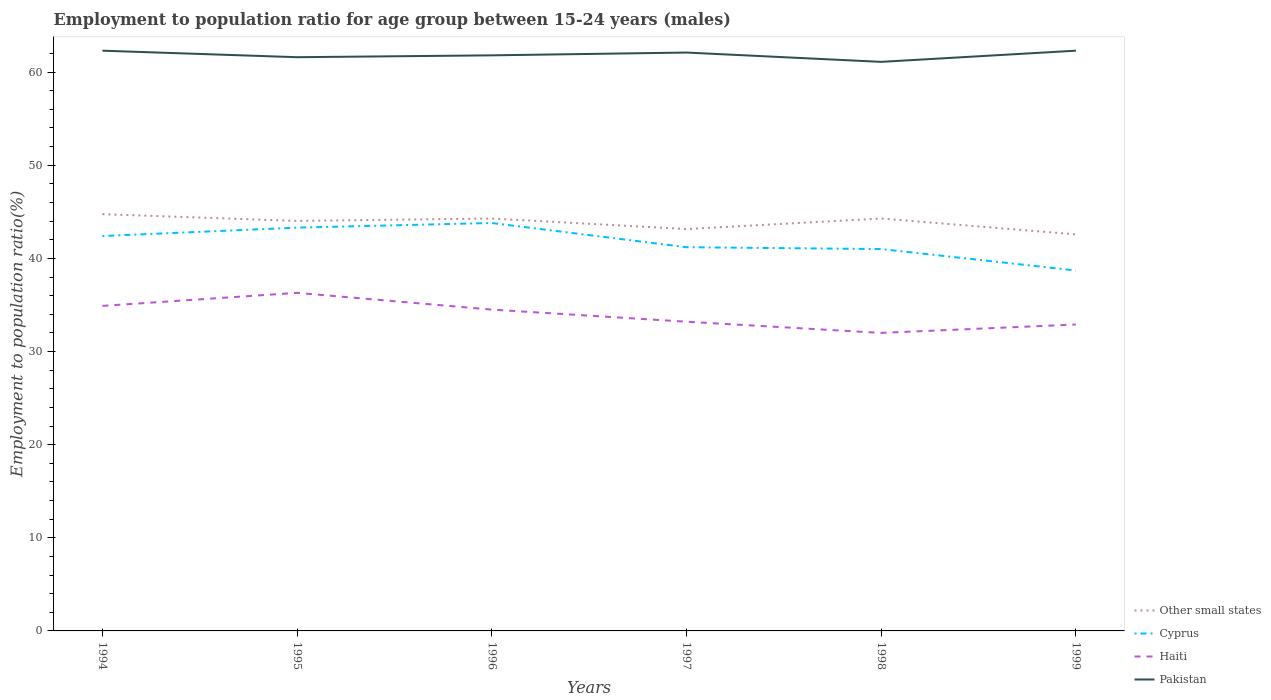Does the line corresponding to Haiti intersect with the line corresponding to Other small states?
Make the answer very short. No. Across all years, what is the maximum employment to population ratio in Other small states?
Your response must be concise. 42.58. In which year was the employment to population ratio in Pakistan maximum?
Your answer should be very brief. 1998. What is the total employment to population ratio in Other small states in the graph?
Provide a short and direct response. 0.57. What is the difference between the highest and the second highest employment to population ratio in Other small states?
Your answer should be very brief. 2.17. Is the employment to population ratio in Haiti strictly greater than the employment to population ratio in Pakistan over the years?
Ensure brevity in your answer.  Yes. How many lines are there?
Ensure brevity in your answer.  4. Does the graph contain any zero values?
Your response must be concise. No. Where does the legend appear in the graph?
Provide a short and direct response. Bottom right. How many legend labels are there?
Provide a short and direct response. 4. How are the legend labels stacked?
Offer a terse response. Vertical. What is the title of the graph?
Provide a short and direct response. Employment to population ratio for age group between 15-24 years (males). Does "Philippines" appear as one of the legend labels in the graph?
Make the answer very short. No. What is the label or title of the X-axis?
Your response must be concise. Years. What is the Employment to population ratio(%) in Other small states in 1994?
Your answer should be very brief. 44.75. What is the Employment to population ratio(%) in Cyprus in 1994?
Offer a terse response. 42.4. What is the Employment to population ratio(%) of Haiti in 1994?
Keep it short and to the point. 34.9. What is the Employment to population ratio(%) in Pakistan in 1994?
Keep it short and to the point. 62.3. What is the Employment to population ratio(%) in Other small states in 1995?
Offer a very short reply. 44.02. What is the Employment to population ratio(%) in Cyprus in 1995?
Give a very brief answer. 43.3. What is the Employment to population ratio(%) in Haiti in 1995?
Provide a short and direct response. 36.3. What is the Employment to population ratio(%) in Pakistan in 1995?
Your answer should be compact. 61.6. What is the Employment to population ratio(%) of Other small states in 1996?
Provide a short and direct response. 44.28. What is the Employment to population ratio(%) in Cyprus in 1996?
Provide a short and direct response. 43.8. What is the Employment to population ratio(%) of Haiti in 1996?
Offer a very short reply. 34.5. What is the Employment to population ratio(%) in Pakistan in 1996?
Your response must be concise. 61.8. What is the Employment to population ratio(%) of Other small states in 1997?
Make the answer very short. 43.15. What is the Employment to population ratio(%) in Cyprus in 1997?
Give a very brief answer. 41.2. What is the Employment to population ratio(%) in Haiti in 1997?
Provide a succinct answer. 33.2. What is the Employment to population ratio(%) of Pakistan in 1997?
Your response must be concise. 62.1. What is the Employment to population ratio(%) of Other small states in 1998?
Ensure brevity in your answer.  44.28. What is the Employment to population ratio(%) in Cyprus in 1998?
Make the answer very short. 41. What is the Employment to population ratio(%) in Haiti in 1998?
Offer a very short reply. 32. What is the Employment to population ratio(%) in Pakistan in 1998?
Offer a terse response. 61.1. What is the Employment to population ratio(%) of Other small states in 1999?
Give a very brief answer. 42.58. What is the Employment to population ratio(%) in Cyprus in 1999?
Offer a very short reply. 38.7. What is the Employment to population ratio(%) of Haiti in 1999?
Make the answer very short. 32.9. What is the Employment to population ratio(%) in Pakistan in 1999?
Ensure brevity in your answer.  62.3. Across all years, what is the maximum Employment to population ratio(%) in Other small states?
Your answer should be very brief. 44.75. Across all years, what is the maximum Employment to population ratio(%) of Cyprus?
Ensure brevity in your answer.  43.8. Across all years, what is the maximum Employment to population ratio(%) in Haiti?
Your response must be concise. 36.3. Across all years, what is the maximum Employment to population ratio(%) in Pakistan?
Your response must be concise. 62.3. Across all years, what is the minimum Employment to population ratio(%) in Other small states?
Your answer should be very brief. 42.58. Across all years, what is the minimum Employment to population ratio(%) in Cyprus?
Make the answer very short. 38.7. Across all years, what is the minimum Employment to population ratio(%) in Pakistan?
Provide a short and direct response. 61.1. What is the total Employment to population ratio(%) of Other small states in the graph?
Your response must be concise. 263.06. What is the total Employment to population ratio(%) of Cyprus in the graph?
Provide a short and direct response. 250.4. What is the total Employment to population ratio(%) in Haiti in the graph?
Ensure brevity in your answer.  203.8. What is the total Employment to population ratio(%) in Pakistan in the graph?
Your answer should be compact. 371.2. What is the difference between the Employment to population ratio(%) of Other small states in 1994 and that in 1995?
Give a very brief answer. 0.73. What is the difference between the Employment to population ratio(%) in Haiti in 1994 and that in 1995?
Your answer should be compact. -1.4. What is the difference between the Employment to population ratio(%) in Pakistan in 1994 and that in 1995?
Give a very brief answer. 0.7. What is the difference between the Employment to population ratio(%) of Other small states in 1994 and that in 1996?
Ensure brevity in your answer.  0.47. What is the difference between the Employment to population ratio(%) of Pakistan in 1994 and that in 1996?
Offer a very short reply. 0.5. What is the difference between the Employment to population ratio(%) in Other small states in 1994 and that in 1997?
Offer a terse response. 1.6. What is the difference between the Employment to population ratio(%) of Pakistan in 1994 and that in 1997?
Give a very brief answer. 0.2. What is the difference between the Employment to population ratio(%) of Other small states in 1994 and that in 1998?
Offer a very short reply. 0.47. What is the difference between the Employment to population ratio(%) of Cyprus in 1994 and that in 1998?
Keep it short and to the point. 1.4. What is the difference between the Employment to population ratio(%) in Haiti in 1994 and that in 1998?
Make the answer very short. 2.9. What is the difference between the Employment to population ratio(%) of Pakistan in 1994 and that in 1998?
Provide a short and direct response. 1.2. What is the difference between the Employment to population ratio(%) in Other small states in 1994 and that in 1999?
Make the answer very short. 2.17. What is the difference between the Employment to population ratio(%) of Cyprus in 1994 and that in 1999?
Offer a very short reply. 3.7. What is the difference between the Employment to population ratio(%) of Pakistan in 1994 and that in 1999?
Provide a succinct answer. 0. What is the difference between the Employment to population ratio(%) of Other small states in 1995 and that in 1996?
Offer a terse response. -0.26. What is the difference between the Employment to population ratio(%) in Cyprus in 1995 and that in 1996?
Ensure brevity in your answer.  -0.5. What is the difference between the Employment to population ratio(%) in Pakistan in 1995 and that in 1996?
Provide a succinct answer. -0.2. What is the difference between the Employment to population ratio(%) of Other small states in 1995 and that in 1997?
Give a very brief answer. 0.87. What is the difference between the Employment to population ratio(%) of Pakistan in 1995 and that in 1997?
Offer a very short reply. -0.5. What is the difference between the Employment to population ratio(%) of Other small states in 1995 and that in 1998?
Offer a very short reply. -0.26. What is the difference between the Employment to population ratio(%) in Pakistan in 1995 and that in 1998?
Your answer should be compact. 0.5. What is the difference between the Employment to population ratio(%) in Other small states in 1995 and that in 1999?
Provide a short and direct response. 1.44. What is the difference between the Employment to population ratio(%) of Cyprus in 1995 and that in 1999?
Your response must be concise. 4.6. What is the difference between the Employment to population ratio(%) of Pakistan in 1995 and that in 1999?
Offer a very short reply. -0.7. What is the difference between the Employment to population ratio(%) in Other small states in 1996 and that in 1997?
Your answer should be compact. 1.13. What is the difference between the Employment to population ratio(%) in Haiti in 1996 and that in 1997?
Ensure brevity in your answer.  1.3. What is the difference between the Employment to population ratio(%) of Pakistan in 1996 and that in 1997?
Keep it short and to the point. -0.3. What is the difference between the Employment to population ratio(%) in Other small states in 1996 and that in 1998?
Provide a short and direct response. -0. What is the difference between the Employment to population ratio(%) of Cyprus in 1996 and that in 1998?
Your answer should be compact. 2.8. What is the difference between the Employment to population ratio(%) in Pakistan in 1996 and that in 1998?
Your answer should be compact. 0.7. What is the difference between the Employment to population ratio(%) of Other small states in 1996 and that in 1999?
Make the answer very short. 1.7. What is the difference between the Employment to population ratio(%) of Haiti in 1996 and that in 1999?
Offer a terse response. 1.6. What is the difference between the Employment to population ratio(%) in Pakistan in 1996 and that in 1999?
Your response must be concise. -0.5. What is the difference between the Employment to population ratio(%) of Other small states in 1997 and that in 1998?
Offer a very short reply. -1.13. What is the difference between the Employment to population ratio(%) of Haiti in 1997 and that in 1998?
Make the answer very short. 1.2. What is the difference between the Employment to population ratio(%) of Other small states in 1997 and that in 1999?
Offer a terse response. 0.57. What is the difference between the Employment to population ratio(%) in Haiti in 1997 and that in 1999?
Keep it short and to the point. 0.3. What is the difference between the Employment to population ratio(%) of Other small states in 1998 and that in 1999?
Your answer should be compact. 1.7. What is the difference between the Employment to population ratio(%) in Cyprus in 1998 and that in 1999?
Keep it short and to the point. 2.3. What is the difference between the Employment to population ratio(%) of Pakistan in 1998 and that in 1999?
Provide a succinct answer. -1.2. What is the difference between the Employment to population ratio(%) in Other small states in 1994 and the Employment to population ratio(%) in Cyprus in 1995?
Keep it short and to the point. 1.45. What is the difference between the Employment to population ratio(%) of Other small states in 1994 and the Employment to population ratio(%) of Haiti in 1995?
Offer a terse response. 8.45. What is the difference between the Employment to population ratio(%) of Other small states in 1994 and the Employment to population ratio(%) of Pakistan in 1995?
Give a very brief answer. -16.85. What is the difference between the Employment to population ratio(%) of Cyprus in 1994 and the Employment to population ratio(%) of Pakistan in 1995?
Give a very brief answer. -19.2. What is the difference between the Employment to population ratio(%) of Haiti in 1994 and the Employment to population ratio(%) of Pakistan in 1995?
Provide a short and direct response. -26.7. What is the difference between the Employment to population ratio(%) in Other small states in 1994 and the Employment to population ratio(%) in Cyprus in 1996?
Offer a terse response. 0.95. What is the difference between the Employment to population ratio(%) in Other small states in 1994 and the Employment to population ratio(%) in Haiti in 1996?
Give a very brief answer. 10.25. What is the difference between the Employment to population ratio(%) of Other small states in 1994 and the Employment to population ratio(%) of Pakistan in 1996?
Provide a short and direct response. -17.05. What is the difference between the Employment to population ratio(%) of Cyprus in 1994 and the Employment to population ratio(%) of Pakistan in 1996?
Offer a very short reply. -19.4. What is the difference between the Employment to population ratio(%) of Haiti in 1994 and the Employment to population ratio(%) of Pakistan in 1996?
Provide a succinct answer. -26.9. What is the difference between the Employment to population ratio(%) of Other small states in 1994 and the Employment to population ratio(%) of Cyprus in 1997?
Your answer should be very brief. 3.55. What is the difference between the Employment to population ratio(%) of Other small states in 1994 and the Employment to population ratio(%) of Haiti in 1997?
Ensure brevity in your answer.  11.55. What is the difference between the Employment to population ratio(%) in Other small states in 1994 and the Employment to population ratio(%) in Pakistan in 1997?
Provide a succinct answer. -17.35. What is the difference between the Employment to population ratio(%) in Cyprus in 1994 and the Employment to population ratio(%) in Haiti in 1997?
Provide a short and direct response. 9.2. What is the difference between the Employment to population ratio(%) of Cyprus in 1994 and the Employment to population ratio(%) of Pakistan in 1997?
Give a very brief answer. -19.7. What is the difference between the Employment to population ratio(%) of Haiti in 1994 and the Employment to population ratio(%) of Pakistan in 1997?
Offer a very short reply. -27.2. What is the difference between the Employment to population ratio(%) in Other small states in 1994 and the Employment to population ratio(%) in Cyprus in 1998?
Keep it short and to the point. 3.75. What is the difference between the Employment to population ratio(%) in Other small states in 1994 and the Employment to population ratio(%) in Haiti in 1998?
Your answer should be very brief. 12.75. What is the difference between the Employment to population ratio(%) of Other small states in 1994 and the Employment to population ratio(%) of Pakistan in 1998?
Provide a succinct answer. -16.35. What is the difference between the Employment to population ratio(%) in Cyprus in 1994 and the Employment to population ratio(%) in Haiti in 1998?
Ensure brevity in your answer.  10.4. What is the difference between the Employment to population ratio(%) in Cyprus in 1994 and the Employment to population ratio(%) in Pakistan in 1998?
Your answer should be compact. -18.7. What is the difference between the Employment to population ratio(%) in Haiti in 1994 and the Employment to population ratio(%) in Pakistan in 1998?
Ensure brevity in your answer.  -26.2. What is the difference between the Employment to population ratio(%) in Other small states in 1994 and the Employment to population ratio(%) in Cyprus in 1999?
Your answer should be very brief. 6.05. What is the difference between the Employment to population ratio(%) of Other small states in 1994 and the Employment to population ratio(%) of Haiti in 1999?
Your response must be concise. 11.85. What is the difference between the Employment to population ratio(%) in Other small states in 1994 and the Employment to population ratio(%) in Pakistan in 1999?
Keep it short and to the point. -17.55. What is the difference between the Employment to population ratio(%) of Cyprus in 1994 and the Employment to population ratio(%) of Pakistan in 1999?
Ensure brevity in your answer.  -19.9. What is the difference between the Employment to population ratio(%) in Haiti in 1994 and the Employment to population ratio(%) in Pakistan in 1999?
Offer a terse response. -27.4. What is the difference between the Employment to population ratio(%) in Other small states in 1995 and the Employment to population ratio(%) in Cyprus in 1996?
Ensure brevity in your answer.  0.22. What is the difference between the Employment to population ratio(%) of Other small states in 1995 and the Employment to population ratio(%) of Haiti in 1996?
Give a very brief answer. 9.52. What is the difference between the Employment to population ratio(%) in Other small states in 1995 and the Employment to population ratio(%) in Pakistan in 1996?
Provide a succinct answer. -17.78. What is the difference between the Employment to population ratio(%) of Cyprus in 1995 and the Employment to population ratio(%) of Haiti in 1996?
Your answer should be very brief. 8.8. What is the difference between the Employment to population ratio(%) in Cyprus in 1995 and the Employment to population ratio(%) in Pakistan in 1996?
Offer a terse response. -18.5. What is the difference between the Employment to population ratio(%) of Haiti in 1995 and the Employment to population ratio(%) of Pakistan in 1996?
Give a very brief answer. -25.5. What is the difference between the Employment to population ratio(%) in Other small states in 1995 and the Employment to population ratio(%) in Cyprus in 1997?
Offer a terse response. 2.82. What is the difference between the Employment to population ratio(%) in Other small states in 1995 and the Employment to population ratio(%) in Haiti in 1997?
Offer a terse response. 10.82. What is the difference between the Employment to population ratio(%) of Other small states in 1995 and the Employment to population ratio(%) of Pakistan in 1997?
Keep it short and to the point. -18.08. What is the difference between the Employment to population ratio(%) in Cyprus in 1995 and the Employment to population ratio(%) in Haiti in 1997?
Provide a short and direct response. 10.1. What is the difference between the Employment to population ratio(%) of Cyprus in 1995 and the Employment to population ratio(%) of Pakistan in 1997?
Make the answer very short. -18.8. What is the difference between the Employment to population ratio(%) of Haiti in 1995 and the Employment to population ratio(%) of Pakistan in 1997?
Make the answer very short. -25.8. What is the difference between the Employment to population ratio(%) in Other small states in 1995 and the Employment to population ratio(%) in Cyprus in 1998?
Ensure brevity in your answer.  3.02. What is the difference between the Employment to population ratio(%) in Other small states in 1995 and the Employment to population ratio(%) in Haiti in 1998?
Offer a terse response. 12.02. What is the difference between the Employment to population ratio(%) in Other small states in 1995 and the Employment to population ratio(%) in Pakistan in 1998?
Your response must be concise. -17.08. What is the difference between the Employment to population ratio(%) of Cyprus in 1995 and the Employment to population ratio(%) of Haiti in 1998?
Offer a very short reply. 11.3. What is the difference between the Employment to population ratio(%) of Cyprus in 1995 and the Employment to population ratio(%) of Pakistan in 1998?
Keep it short and to the point. -17.8. What is the difference between the Employment to population ratio(%) in Haiti in 1995 and the Employment to population ratio(%) in Pakistan in 1998?
Ensure brevity in your answer.  -24.8. What is the difference between the Employment to population ratio(%) in Other small states in 1995 and the Employment to population ratio(%) in Cyprus in 1999?
Give a very brief answer. 5.32. What is the difference between the Employment to population ratio(%) in Other small states in 1995 and the Employment to population ratio(%) in Haiti in 1999?
Your answer should be compact. 11.12. What is the difference between the Employment to population ratio(%) in Other small states in 1995 and the Employment to population ratio(%) in Pakistan in 1999?
Ensure brevity in your answer.  -18.28. What is the difference between the Employment to population ratio(%) of Cyprus in 1995 and the Employment to population ratio(%) of Pakistan in 1999?
Provide a succinct answer. -19. What is the difference between the Employment to population ratio(%) of Haiti in 1995 and the Employment to population ratio(%) of Pakistan in 1999?
Offer a very short reply. -26. What is the difference between the Employment to population ratio(%) of Other small states in 1996 and the Employment to population ratio(%) of Cyprus in 1997?
Offer a very short reply. 3.08. What is the difference between the Employment to population ratio(%) in Other small states in 1996 and the Employment to population ratio(%) in Haiti in 1997?
Make the answer very short. 11.08. What is the difference between the Employment to population ratio(%) in Other small states in 1996 and the Employment to population ratio(%) in Pakistan in 1997?
Provide a short and direct response. -17.82. What is the difference between the Employment to population ratio(%) in Cyprus in 1996 and the Employment to population ratio(%) in Haiti in 1997?
Offer a terse response. 10.6. What is the difference between the Employment to population ratio(%) of Cyprus in 1996 and the Employment to population ratio(%) of Pakistan in 1997?
Make the answer very short. -18.3. What is the difference between the Employment to population ratio(%) in Haiti in 1996 and the Employment to population ratio(%) in Pakistan in 1997?
Give a very brief answer. -27.6. What is the difference between the Employment to population ratio(%) in Other small states in 1996 and the Employment to population ratio(%) in Cyprus in 1998?
Make the answer very short. 3.28. What is the difference between the Employment to population ratio(%) of Other small states in 1996 and the Employment to population ratio(%) of Haiti in 1998?
Your answer should be very brief. 12.28. What is the difference between the Employment to population ratio(%) in Other small states in 1996 and the Employment to population ratio(%) in Pakistan in 1998?
Provide a short and direct response. -16.82. What is the difference between the Employment to population ratio(%) of Cyprus in 1996 and the Employment to population ratio(%) of Pakistan in 1998?
Offer a terse response. -17.3. What is the difference between the Employment to population ratio(%) in Haiti in 1996 and the Employment to population ratio(%) in Pakistan in 1998?
Your answer should be very brief. -26.6. What is the difference between the Employment to population ratio(%) in Other small states in 1996 and the Employment to population ratio(%) in Cyprus in 1999?
Keep it short and to the point. 5.58. What is the difference between the Employment to population ratio(%) in Other small states in 1996 and the Employment to population ratio(%) in Haiti in 1999?
Your answer should be very brief. 11.38. What is the difference between the Employment to population ratio(%) in Other small states in 1996 and the Employment to population ratio(%) in Pakistan in 1999?
Your response must be concise. -18.02. What is the difference between the Employment to population ratio(%) in Cyprus in 1996 and the Employment to population ratio(%) in Haiti in 1999?
Provide a short and direct response. 10.9. What is the difference between the Employment to population ratio(%) in Cyprus in 1996 and the Employment to population ratio(%) in Pakistan in 1999?
Provide a succinct answer. -18.5. What is the difference between the Employment to population ratio(%) of Haiti in 1996 and the Employment to population ratio(%) of Pakistan in 1999?
Offer a terse response. -27.8. What is the difference between the Employment to population ratio(%) in Other small states in 1997 and the Employment to population ratio(%) in Cyprus in 1998?
Ensure brevity in your answer.  2.15. What is the difference between the Employment to population ratio(%) of Other small states in 1997 and the Employment to population ratio(%) of Haiti in 1998?
Your response must be concise. 11.15. What is the difference between the Employment to population ratio(%) of Other small states in 1997 and the Employment to population ratio(%) of Pakistan in 1998?
Ensure brevity in your answer.  -17.95. What is the difference between the Employment to population ratio(%) of Cyprus in 1997 and the Employment to population ratio(%) of Pakistan in 1998?
Make the answer very short. -19.9. What is the difference between the Employment to population ratio(%) in Haiti in 1997 and the Employment to population ratio(%) in Pakistan in 1998?
Keep it short and to the point. -27.9. What is the difference between the Employment to population ratio(%) of Other small states in 1997 and the Employment to population ratio(%) of Cyprus in 1999?
Your answer should be very brief. 4.45. What is the difference between the Employment to population ratio(%) in Other small states in 1997 and the Employment to population ratio(%) in Haiti in 1999?
Offer a terse response. 10.25. What is the difference between the Employment to population ratio(%) in Other small states in 1997 and the Employment to population ratio(%) in Pakistan in 1999?
Your answer should be compact. -19.15. What is the difference between the Employment to population ratio(%) in Cyprus in 1997 and the Employment to population ratio(%) in Pakistan in 1999?
Offer a very short reply. -21.1. What is the difference between the Employment to population ratio(%) of Haiti in 1997 and the Employment to population ratio(%) of Pakistan in 1999?
Offer a very short reply. -29.1. What is the difference between the Employment to population ratio(%) in Other small states in 1998 and the Employment to population ratio(%) in Cyprus in 1999?
Offer a terse response. 5.58. What is the difference between the Employment to population ratio(%) of Other small states in 1998 and the Employment to population ratio(%) of Haiti in 1999?
Make the answer very short. 11.38. What is the difference between the Employment to population ratio(%) of Other small states in 1998 and the Employment to population ratio(%) of Pakistan in 1999?
Make the answer very short. -18.02. What is the difference between the Employment to population ratio(%) of Cyprus in 1998 and the Employment to population ratio(%) of Haiti in 1999?
Your answer should be compact. 8.1. What is the difference between the Employment to population ratio(%) of Cyprus in 1998 and the Employment to population ratio(%) of Pakistan in 1999?
Offer a very short reply. -21.3. What is the difference between the Employment to population ratio(%) in Haiti in 1998 and the Employment to population ratio(%) in Pakistan in 1999?
Provide a succinct answer. -30.3. What is the average Employment to population ratio(%) of Other small states per year?
Your answer should be very brief. 43.84. What is the average Employment to population ratio(%) of Cyprus per year?
Ensure brevity in your answer.  41.73. What is the average Employment to population ratio(%) in Haiti per year?
Offer a terse response. 33.97. What is the average Employment to population ratio(%) of Pakistan per year?
Make the answer very short. 61.87. In the year 1994, what is the difference between the Employment to population ratio(%) in Other small states and Employment to population ratio(%) in Cyprus?
Provide a short and direct response. 2.35. In the year 1994, what is the difference between the Employment to population ratio(%) in Other small states and Employment to population ratio(%) in Haiti?
Ensure brevity in your answer.  9.85. In the year 1994, what is the difference between the Employment to population ratio(%) in Other small states and Employment to population ratio(%) in Pakistan?
Provide a short and direct response. -17.55. In the year 1994, what is the difference between the Employment to population ratio(%) of Cyprus and Employment to population ratio(%) of Pakistan?
Your answer should be very brief. -19.9. In the year 1994, what is the difference between the Employment to population ratio(%) in Haiti and Employment to population ratio(%) in Pakistan?
Provide a succinct answer. -27.4. In the year 1995, what is the difference between the Employment to population ratio(%) of Other small states and Employment to population ratio(%) of Cyprus?
Your answer should be very brief. 0.72. In the year 1995, what is the difference between the Employment to population ratio(%) of Other small states and Employment to population ratio(%) of Haiti?
Provide a short and direct response. 7.72. In the year 1995, what is the difference between the Employment to population ratio(%) in Other small states and Employment to population ratio(%) in Pakistan?
Make the answer very short. -17.58. In the year 1995, what is the difference between the Employment to population ratio(%) of Cyprus and Employment to population ratio(%) of Pakistan?
Your answer should be very brief. -18.3. In the year 1995, what is the difference between the Employment to population ratio(%) of Haiti and Employment to population ratio(%) of Pakistan?
Offer a very short reply. -25.3. In the year 1996, what is the difference between the Employment to population ratio(%) of Other small states and Employment to population ratio(%) of Cyprus?
Your answer should be very brief. 0.48. In the year 1996, what is the difference between the Employment to population ratio(%) of Other small states and Employment to population ratio(%) of Haiti?
Offer a very short reply. 9.78. In the year 1996, what is the difference between the Employment to population ratio(%) in Other small states and Employment to population ratio(%) in Pakistan?
Offer a terse response. -17.52. In the year 1996, what is the difference between the Employment to population ratio(%) of Haiti and Employment to population ratio(%) of Pakistan?
Provide a succinct answer. -27.3. In the year 1997, what is the difference between the Employment to population ratio(%) in Other small states and Employment to population ratio(%) in Cyprus?
Your answer should be very brief. 1.95. In the year 1997, what is the difference between the Employment to population ratio(%) in Other small states and Employment to population ratio(%) in Haiti?
Your answer should be very brief. 9.95. In the year 1997, what is the difference between the Employment to population ratio(%) in Other small states and Employment to population ratio(%) in Pakistan?
Give a very brief answer. -18.95. In the year 1997, what is the difference between the Employment to population ratio(%) in Cyprus and Employment to population ratio(%) in Pakistan?
Your answer should be compact. -20.9. In the year 1997, what is the difference between the Employment to population ratio(%) of Haiti and Employment to population ratio(%) of Pakistan?
Give a very brief answer. -28.9. In the year 1998, what is the difference between the Employment to population ratio(%) of Other small states and Employment to population ratio(%) of Cyprus?
Ensure brevity in your answer.  3.28. In the year 1998, what is the difference between the Employment to population ratio(%) of Other small states and Employment to population ratio(%) of Haiti?
Your response must be concise. 12.28. In the year 1998, what is the difference between the Employment to population ratio(%) of Other small states and Employment to population ratio(%) of Pakistan?
Provide a succinct answer. -16.82. In the year 1998, what is the difference between the Employment to population ratio(%) of Cyprus and Employment to population ratio(%) of Haiti?
Your response must be concise. 9. In the year 1998, what is the difference between the Employment to population ratio(%) in Cyprus and Employment to population ratio(%) in Pakistan?
Your response must be concise. -20.1. In the year 1998, what is the difference between the Employment to population ratio(%) of Haiti and Employment to population ratio(%) of Pakistan?
Offer a very short reply. -29.1. In the year 1999, what is the difference between the Employment to population ratio(%) in Other small states and Employment to population ratio(%) in Cyprus?
Make the answer very short. 3.88. In the year 1999, what is the difference between the Employment to population ratio(%) of Other small states and Employment to population ratio(%) of Haiti?
Offer a very short reply. 9.68. In the year 1999, what is the difference between the Employment to population ratio(%) in Other small states and Employment to population ratio(%) in Pakistan?
Provide a succinct answer. -19.72. In the year 1999, what is the difference between the Employment to population ratio(%) in Cyprus and Employment to population ratio(%) in Pakistan?
Provide a succinct answer. -23.6. In the year 1999, what is the difference between the Employment to population ratio(%) in Haiti and Employment to population ratio(%) in Pakistan?
Your response must be concise. -29.4. What is the ratio of the Employment to population ratio(%) in Other small states in 1994 to that in 1995?
Provide a short and direct response. 1.02. What is the ratio of the Employment to population ratio(%) in Cyprus in 1994 to that in 1995?
Keep it short and to the point. 0.98. What is the ratio of the Employment to population ratio(%) of Haiti in 1994 to that in 1995?
Offer a terse response. 0.96. What is the ratio of the Employment to population ratio(%) of Pakistan in 1994 to that in 1995?
Make the answer very short. 1.01. What is the ratio of the Employment to population ratio(%) in Other small states in 1994 to that in 1996?
Offer a very short reply. 1.01. What is the ratio of the Employment to population ratio(%) of Haiti in 1994 to that in 1996?
Offer a terse response. 1.01. What is the ratio of the Employment to population ratio(%) of Pakistan in 1994 to that in 1996?
Your answer should be very brief. 1.01. What is the ratio of the Employment to population ratio(%) in Other small states in 1994 to that in 1997?
Ensure brevity in your answer.  1.04. What is the ratio of the Employment to population ratio(%) of Cyprus in 1994 to that in 1997?
Ensure brevity in your answer.  1.03. What is the ratio of the Employment to population ratio(%) in Haiti in 1994 to that in 1997?
Give a very brief answer. 1.05. What is the ratio of the Employment to population ratio(%) of Pakistan in 1994 to that in 1997?
Your answer should be very brief. 1. What is the ratio of the Employment to population ratio(%) in Other small states in 1994 to that in 1998?
Keep it short and to the point. 1.01. What is the ratio of the Employment to population ratio(%) of Cyprus in 1994 to that in 1998?
Offer a terse response. 1.03. What is the ratio of the Employment to population ratio(%) in Haiti in 1994 to that in 1998?
Give a very brief answer. 1.09. What is the ratio of the Employment to population ratio(%) of Pakistan in 1994 to that in 1998?
Offer a very short reply. 1.02. What is the ratio of the Employment to population ratio(%) of Other small states in 1994 to that in 1999?
Ensure brevity in your answer.  1.05. What is the ratio of the Employment to population ratio(%) of Cyprus in 1994 to that in 1999?
Ensure brevity in your answer.  1.1. What is the ratio of the Employment to population ratio(%) of Haiti in 1994 to that in 1999?
Offer a very short reply. 1.06. What is the ratio of the Employment to population ratio(%) of Haiti in 1995 to that in 1996?
Keep it short and to the point. 1.05. What is the ratio of the Employment to population ratio(%) in Other small states in 1995 to that in 1997?
Give a very brief answer. 1.02. What is the ratio of the Employment to population ratio(%) of Cyprus in 1995 to that in 1997?
Provide a short and direct response. 1.05. What is the ratio of the Employment to population ratio(%) of Haiti in 1995 to that in 1997?
Your answer should be very brief. 1.09. What is the ratio of the Employment to population ratio(%) in Cyprus in 1995 to that in 1998?
Make the answer very short. 1.06. What is the ratio of the Employment to population ratio(%) of Haiti in 1995 to that in 1998?
Ensure brevity in your answer.  1.13. What is the ratio of the Employment to population ratio(%) of Pakistan in 1995 to that in 1998?
Keep it short and to the point. 1.01. What is the ratio of the Employment to population ratio(%) in Other small states in 1995 to that in 1999?
Your answer should be compact. 1.03. What is the ratio of the Employment to population ratio(%) in Cyprus in 1995 to that in 1999?
Your answer should be compact. 1.12. What is the ratio of the Employment to population ratio(%) in Haiti in 1995 to that in 1999?
Give a very brief answer. 1.1. What is the ratio of the Employment to population ratio(%) of Pakistan in 1995 to that in 1999?
Offer a very short reply. 0.99. What is the ratio of the Employment to population ratio(%) in Other small states in 1996 to that in 1997?
Provide a succinct answer. 1.03. What is the ratio of the Employment to population ratio(%) in Cyprus in 1996 to that in 1997?
Your response must be concise. 1.06. What is the ratio of the Employment to population ratio(%) of Haiti in 1996 to that in 1997?
Your response must be concise. 1.04. What is the ratio of the Employment to population ratio(%) in Cyprus in 1996 to that in 1998?
Your answer should be very brief. 1.07. What is the ratio of the Employment to population ratio(%) in Haiti in 1996 to that in 1998?
Your response must be concise. 1.08. What is the ratio of the Employment to population ratio(%) of Pakistan in 1996 to that in 1998?
Make the answer very short. 1.01. What is the ratio of the Employment to population ratio(%) in Other small states in 1996 to that in 1999?
Offer a terse response. 1.04. What is the ratio of the Employment to population ratio(%) in Cyprus in 1996 to that in 1999?
Your answer should be compact. 1.13. What is the ratio of the Employment to population ratio(%) in Haiti in 1996 to that in 1999?
Offer a very short reply. 1.05. What is the ratio of the Employment to population ratio(%) in Pakistan in 1996 to that in 1999?
Keep it short and to the point. 0.99. What is the ratio of the Employment to population ratio(%) of Other small states in 1997 to that in 1998?
Make the answer very short. 0.97. What is the ratio of the Employment to population ratio(%) in Haiti in 1997 to that in 1998?
Ensure brevity in your answer.  1.04. What is the ratio of the Employment to population ratio(%) of Pakistan in 1997 to that in 1998?
Your answer should be very brief. 1.02. What is the ratio of the Employment to population ratio(%) of Other small states in 1997 to that in 1999?
Your answer should be very brief. 1.01. What is the ratio of the Employment to population ratio(%) in Cyprus in 1997 to that in 1999?
Offer a very short reply. 1.06. What is the ratio of the Employment to population ratio(%) of Haiti in 1997 to that in 1999?
Your answer should be compact. 1.01. What is the ratio of the Employment to population ratio(%) of Other small states in 1998 to that in 1999?
Provide a succinct answer. 1.04. What is the ratio of the Employment to population ratio(%) in Cyprus in 1998 to that in 1999?
Provide a short and direct response. 1.06. What is the ratio of the Employment to population ratio(%) in Haiti in 1998 to that in 1999?
Keep it short and to the point. 0.97. What is the ratio of the Employment to population ratio(%) of Pakistan in 1998 to that in 1999?
Ensure brevity in your answer.  0.98. What is the difference between the highest and the second highest Employment to population ratio(%) of Other small states?
Your answer should be very brief. 0.47. What is the difference between the highest and the second highest Employment to population ratio(%) of Cyprus?
Provide a succinct answer. 0.5. What is the difference between the highest and the second highest Employment to population ratio(%) of Pakistan?
Offer a terse response. 0. What is the difference between the highest and the lowest Employment to population ratio(%) of Other small states?
Your answer should be compact. 2.17. What is the difference between the highest and the lowest Employment to population ratio(%) in Pakistan?
Provide a short and direct response. 1.2. 